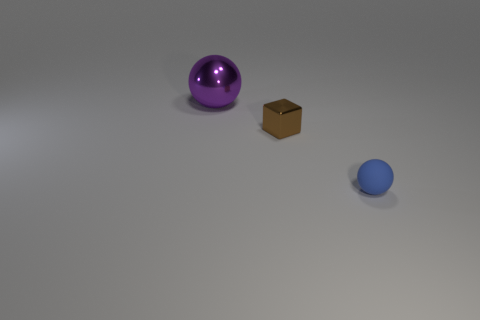Add 1 tiny metallic cylinders. How many objects exist? 4 Add 3 small red metallic balls. How many small red metallic balls exist? 3 Subtract 0 red blocks. How many objects are left? 3 Subtract all cubes. How many objects are left? 2 Subtract all large red balls. Subtract all matte objects. How many objects are left? 2 Add 3 cubes. How many cubes are left? 4 